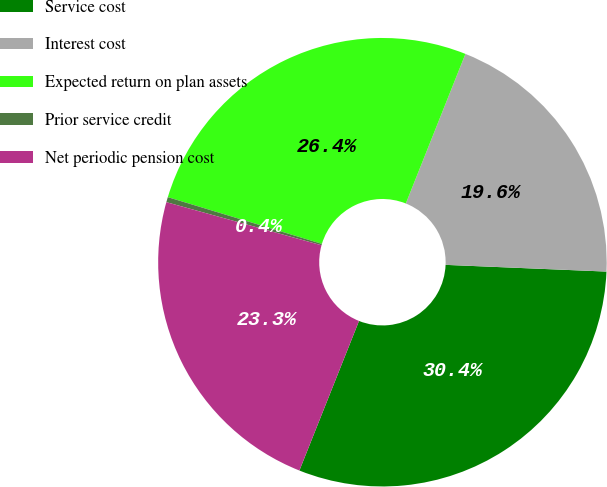Convert chart to OTSL. <chart><loc_0><loc_0><loc_500><loc_500><pie_chart><fcel>Service cost<fcel>Interest cost<fcel>Expected return on plan assets<fcel>Prior service credit<fcel>Net periodic pension cost<nl><fcel>30.37%<fcel>19.63%<fcel>26.35%<fcel>0.37%<fcel>23.28%<nl></chart> 